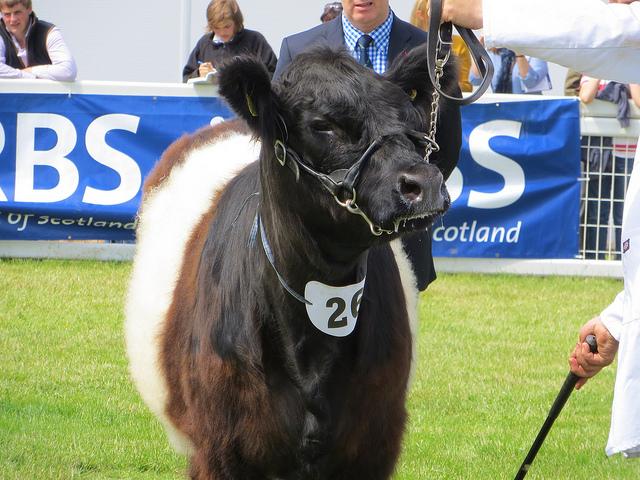What kind of animal is in this scene?
Answer briefly. Cow. How many cows are in the picture?
Be succinct. 1. What are they doing with this animal?
Short answer required. Showing. 